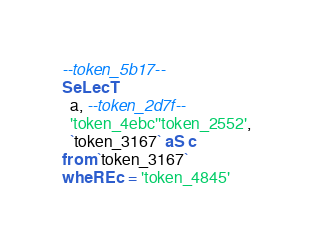<code> <loc_0><loc_0><loc_500><loc_500><_SQL_>
--token_5b17--
SeLecT
  a, --token_2d7f--
  'token_4ebc''token_2552',
  `token_3167` aS c
from `token_3167`
wheRE c = 'token_4845'</code> 